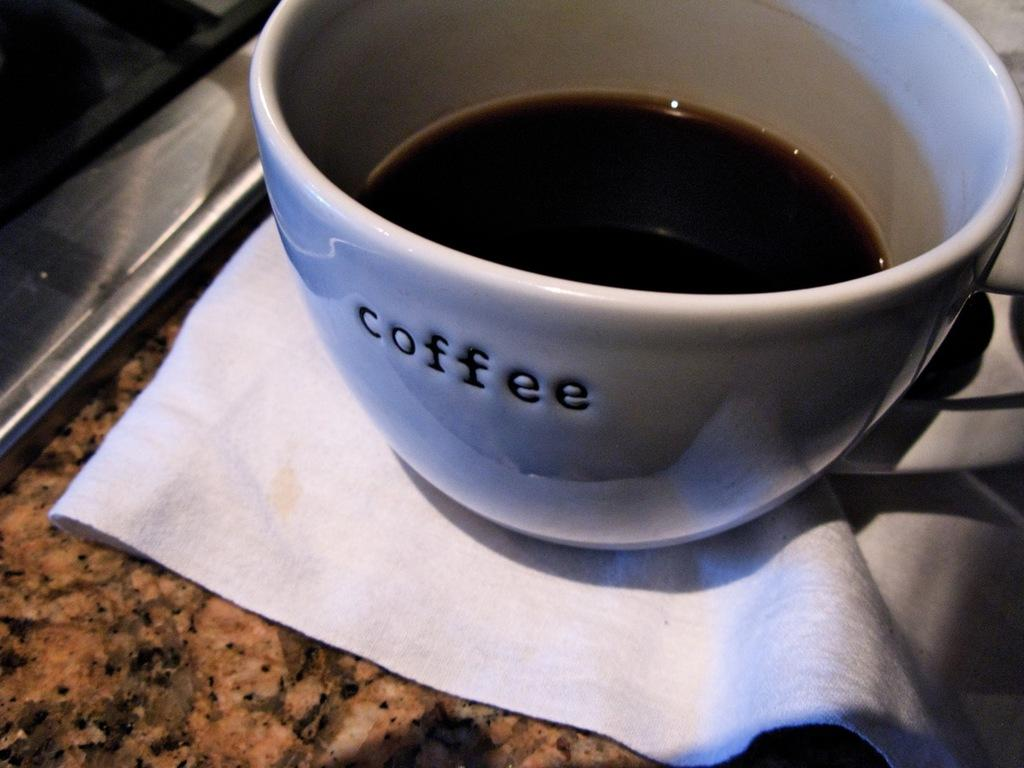What is present on the countertop in the image? There is a coffee cup and a napkin on the countertop in the image. What might be used for cleaning or wiping in the image? The napkin in the image can be used for cleaning or wiping. What is the primary object on the countertop in the image? The primary object on the countertop in the image is the coffee cup. Can you see a parcel being delivered by a magical creature in the image? No, there is no parcel or magical creature present in the image. What type of whistle is being used by the coffee cup in the image? There is no whistle associated with the coffee cup in the image. 